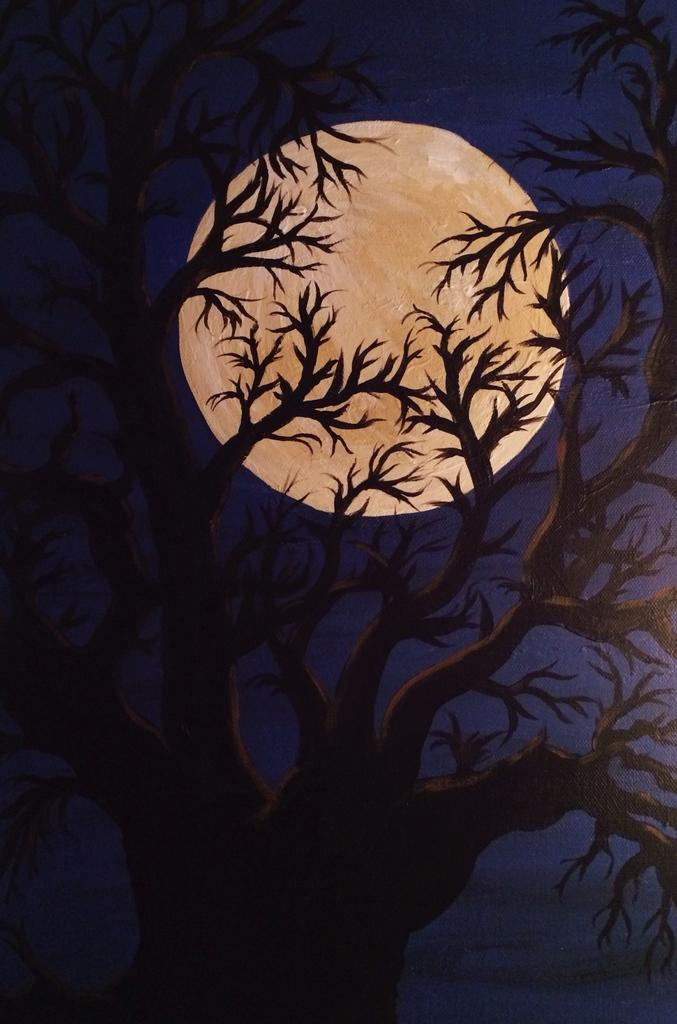What is present on the paper in the image? The paper has a painting on it. What is depicted in the painting? The painting depicts a tree and a moon in the sky. What color is the orange in the image? There is no orange present in the image; the painting depicts a tree and a moon in the sky. 